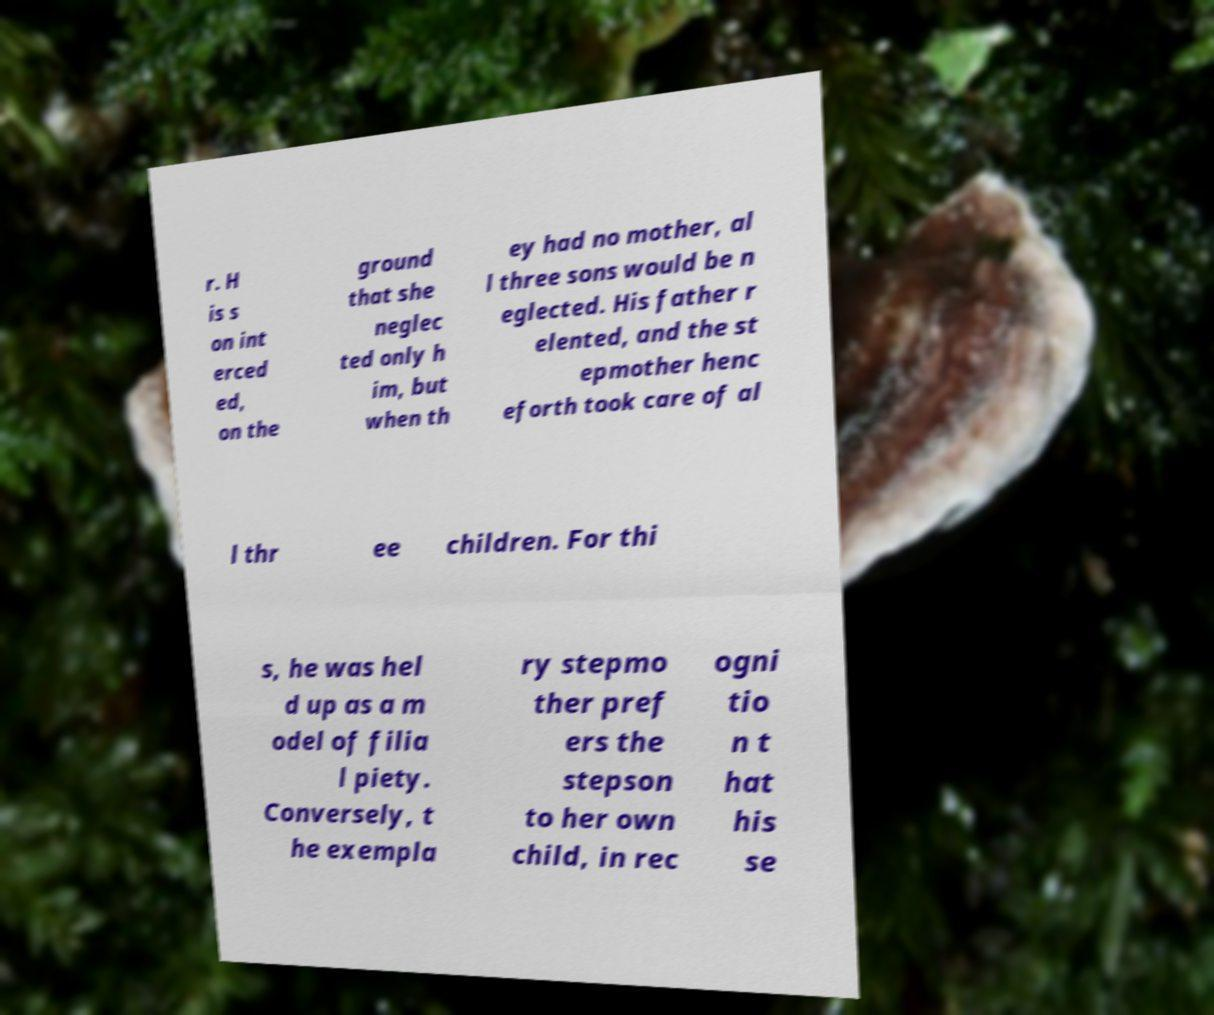There's text embedded in this image that I need extracted. Can you transcribe it verbatim? r. H is s on int erced ed, on the ground that she neglec ted only h im, but when th ey had no mother, al l three sons would be n eglected. His father r elented, and the st epmother henc eforth took care of al l thr ee children. For thi s, he was hel d up as a m odel of filia l piety. Conversely, t he exempla ry stepmo ther pref ers the stepson to her own child, in rec ogni tio n t hat his se 